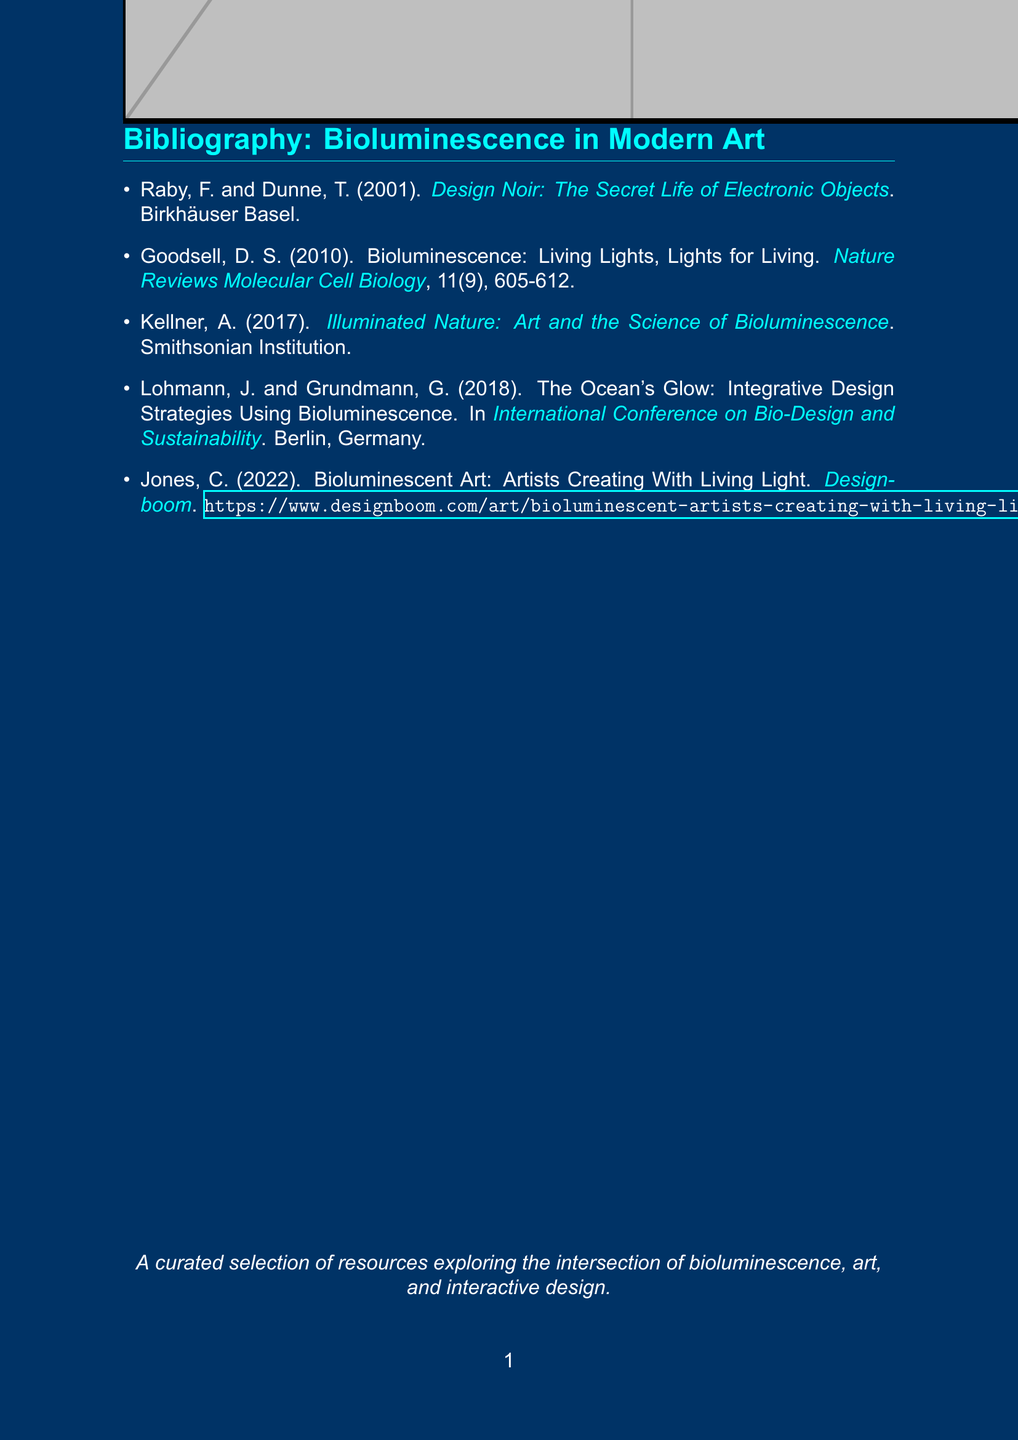What is the title of the document? The title is stated in the document as a bibliographic entry.
Answer: Bibliography: Bioluminescence in Modern Art Who are the authors of "Design Noir"? The authors are listed in the bibliography entry for this book.
Answer: Raby, F. and Dunne, T What year was "Bioluminescence: Living Lights, Lights for Living" published? The publication year is mentioned in the citation of the document.
Answer: 2010 What type of publication is the source by Jones, C.? This is indicated in the document, clearly defining the format of the work.
Answer: Article How many items are listed in the bibliography? The total number of references can be counted by looking at the list presented.
Answer: 5 Which institution published "Illuminated Nature"? The publishing entity is specified in the citation of this resource.
Answer: Smithsonian Institution In which city was the International Conference on Bio-Design and Sustainability held? This information can be found in the entry for the conference in the bibliography.
Answer: Berlin, Germany What is the color used for the titles in the bibliography? The document defines specific colors used throughout, including for titles.
Answer: Bioluminescent Which journal published Goodsell's work? The journal is explicitly named in the citation of the document.
Answer: Nature Reviews Molecular Cell Biology 